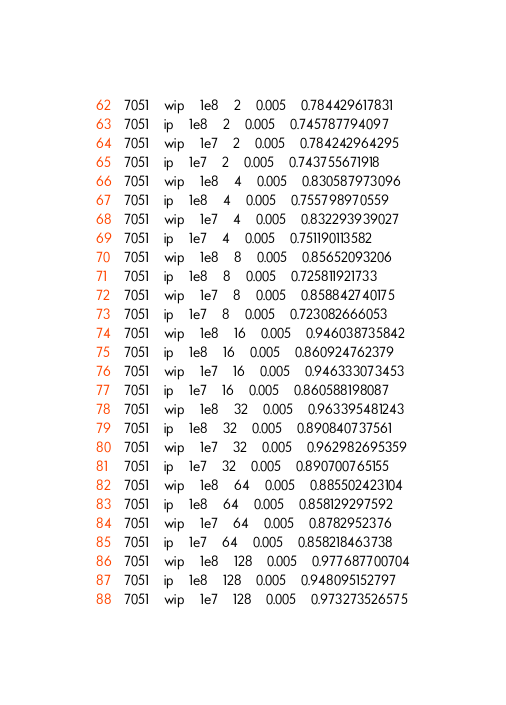Convert code to text. <code><loc_0><loc_0><loc_500><loc_500><_SQL_>7051	wip	1e8	2	0.005	0.784429617831
7051	ip	1e8	2	0.005	0.745787794097
7051	wip	1e7	2	0.005	0.784242964295
7051	ip	1e7	2	0.005	0.743755671918
7051	wip	1e8	4	0.005	0.830587973096
7051	ip	1e8	4	0.005	0.755798970559
7051	wip	1e7	4	0.005	0.832293939027
7051	ip	1e7	4	0.005	0.751190113582
7051	wip	1e8	8	0.005	0.85652093206
7051	ip	1e8	8	0.005	0.725811921733
7051	wip	1e7	8	0.005	0.858842740175
7051	ip	1e7	8	0.005	0.723082666053
7051	wip	1e8	16	0.005	0.946038735842
7051	ip	1e8	16	0.005	0.860924762379
7051	wip	1e7	16	0.005	0.946333073453
7051	ip	1e7	16	0.005	0.860588198087
7051	wip	1e8	32	0.005	0.963395481243
7051	ip	1e8	32	0.005	0.890840737561
7051	wip	1e7	32	0.005	0.962982695359
7051	ip	1e7	32	0.005	0.890700765155
7051	wip	1e8	64	0.005	0.885502423104
7051	ip	1e8	64	0.005	0.858129297592
7051	wip	1e7	64	0.005	0.8782952376
7051	ip	1e7	64	0.005	0.858218463738
7051	wip	1e8	128	0.005	0.977687700704
7051	ip	1e8	128	0.005	0.948095152797
7051	wip	1e7	128	0.005	0.973273526575</code> 